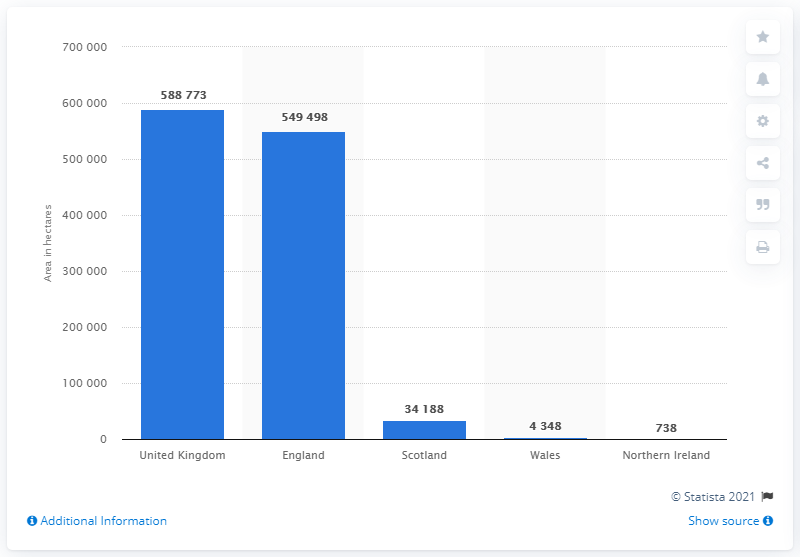Mention a couple of crucial points in this snapshot. In June 2017, approximately 549,498 hectares of rapeseed were grown in England. 